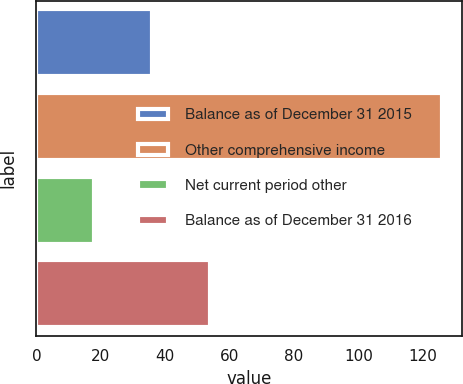Convert chart. <chart><loc_0><loc_0><loc_500><loc_500><bar_chart><fcel>Balance as of December 31 2015<fcel>Other comprehensive income<fcel>Net current period other<fcel>Balance as of December 31 2016<nl><fcel>36<fcel>126<fcel>18<fcel>54<nl></chart> 